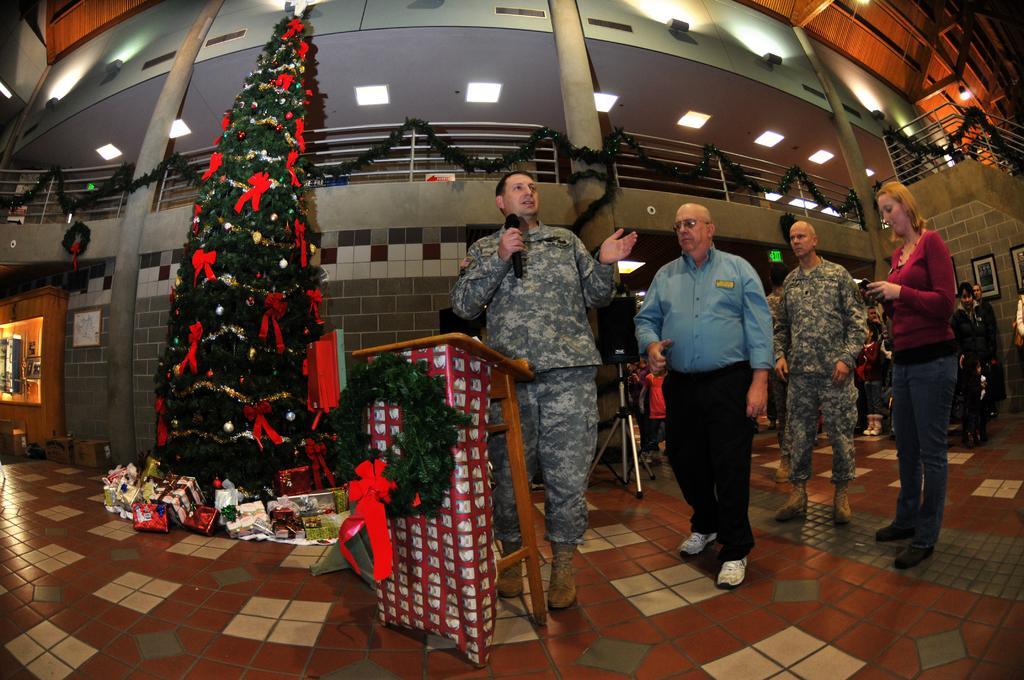In one or two sentences, can you explain what this image depicts? In this image, we can see people and some are wearing uniforms and one of them is holding a mic and we can see a podium and a garland. In the background, there is a christmas tree and we can see some boxes and there are garlands hanging and we can see frames on the wall and there are lights and a stand with a box. At the bottom, there is a floor. 